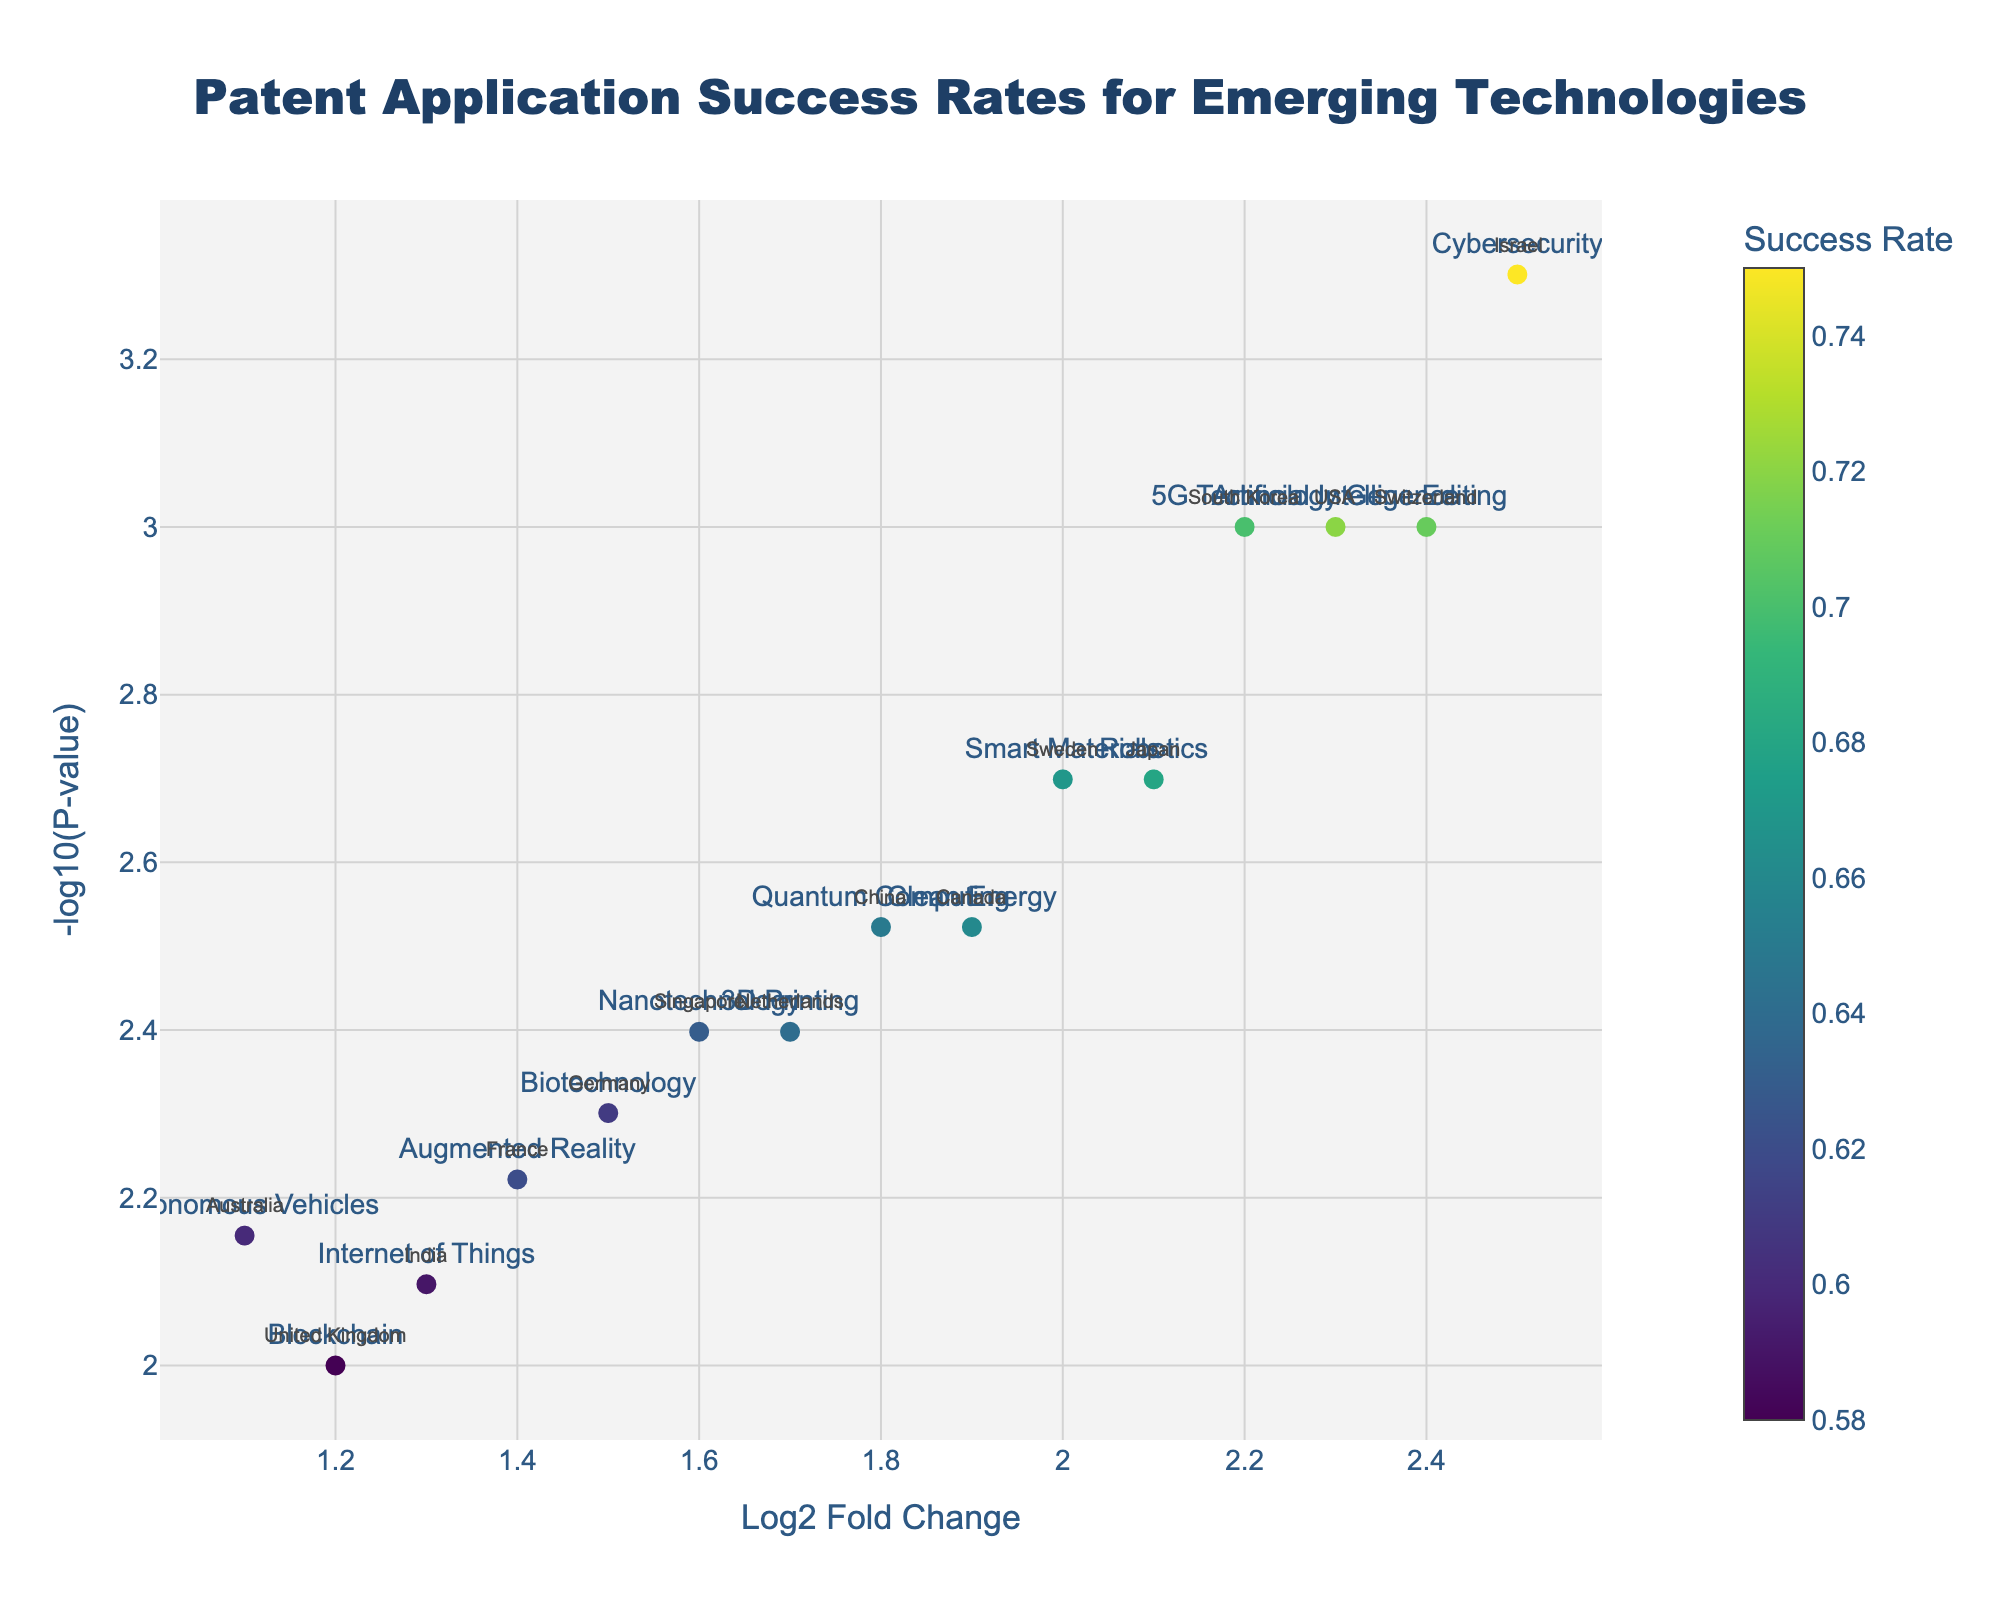What is the title of the plot? The title of the plot is clearly displayed at the top center of the figure. It reads "Patent Application Success Rates for Emerging Technologies."
Answer: Patent Application Success Rates for Emerging Technologies Which country has the highest success rate in patent applications? To find the country with the highest success rate, we look for the marker with the highest color value according to the colorscale. The hover text or color bar indicates that Israel's Cybersecurity technology has the highest success rate at 0.75.
Answer: Israel What is the y-axis title? The y-axis title is shown on the vertical axis of the plot. It is labeled "-log10(P-value)," indicating it represents the transformation of the P-value for statistical significance.
Answer: -log10(P-value) What is the log2 fold change for Quantum Computing in China? From the plot, locate the text annotation for Quantum Computing and refer to the x-coordinate of this annotated point. The log2 fold change value provided in the data for China is 1.8.
Answer: 1.8 Among the countries shown, which emerging technology has the lowest success rate? By examining the colors and annotations, the technology with the lowest success rate will have the most muted color according to the colorscale. The UK’s Blockchain technology, with a success rate of 0.58, is the lowest.
Answer: Blockchain in the UK Which country and technology combination shows the most statistically significant P-value? The most statistically significant P-value will have the highest y-coordinate value (largest -log10 transformation). Israel's Cybersecurity has the highest point on the y-axis, corresponding to a P-value of 0.0005.
Answer: Israel, Cybersecurity Compare the success rates of Biotechnology in Germany and Clean Energy in Canada. Which one is higher? First, identify the points labeled as Biotechnology and Clean Energy. Then, refer to their colors on the colorscale. Biotechnology has a success rate of 0.61, while Clean Energy has a success rate of 0.66. Therefore, Clean Energy in Canada has a higher success rate.
Answer: Clean Energy in Canada What is the mean log2 fold change of the technologies related to Switzerland and Netherlands? Determine the log2 fold changes for Switzerland (Gene Editing, 2.4) and Netherlands (3D Printing, 1.7). The mean is calculated as (2.4 + 1.7) / 2 = 2.05.
Answer: 2.05 How many emerging technologies have a P-value less than 0.005? Look at the y-axis and find the threshold equivalent to -log10(0.005). Markers above this y-axis threshold indicate P-values less than 0.005. The technologies that qualify are AI (USA), Robotics (Japan), 5G (South Korea), Cybersecurity (Israel), Gene Editing (Switzerland), Quantum Computing (China), Clean Energy (Canada), and Nanotechnology (Singapore). Count these annotations to get the total.
Answer: 8 Which technologies show a log2 fold change greater than 2? Check the x-coordinates of the points and identify those to the right of the line at 2 on the x-axis. These technologies in the data are Artificial Intelligence (USA), Cybersecurity (Israel), 5G Technology (South Korea), Gene Editing (Switzerland), and Robotics (Japan).
Answer: AI, Cybersecurity, 5G, Gene Editing, Robotics 